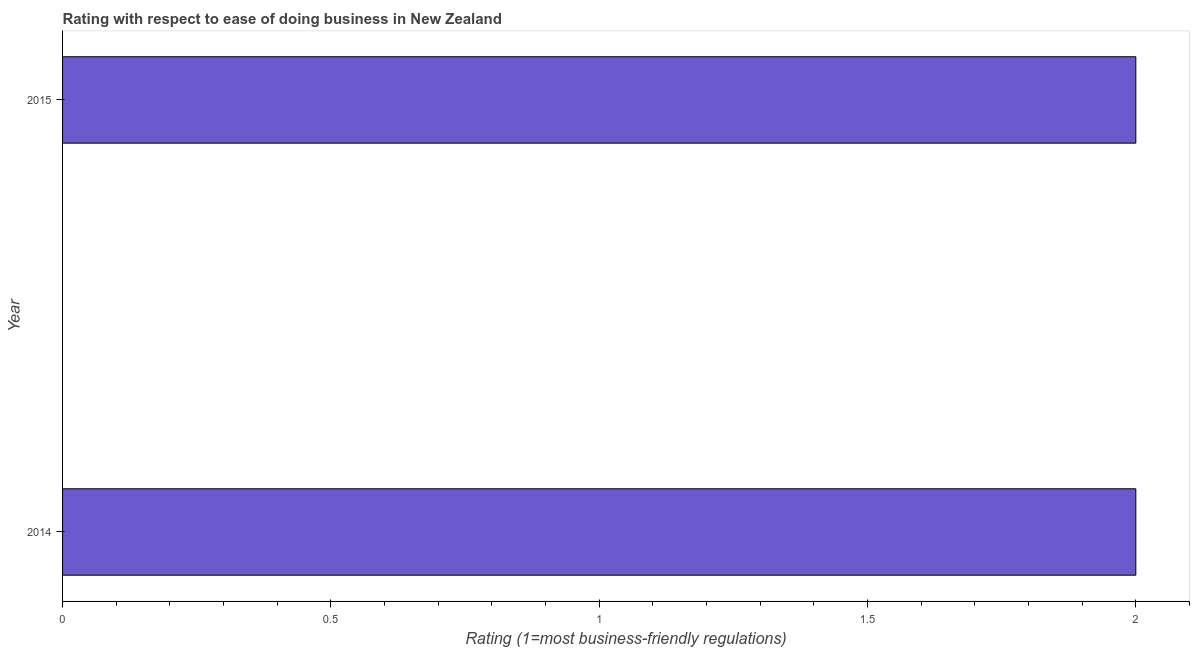Does the graph contain any zero values?
Give a very brief answer. No. Does the graph contain grids?
Your answer should be very brief. No. What is the title of the graph?
Give a very brief answer. Rating with respect to ease of doing business in New Zealand. What is the label or title of the X-axis?
Ensure brevity in your answer.  Rating (1=most business-friendly regulations). Across all years, what is the maximum ease of doing business index?
Keep it short and to the point. 2. What is the difference between the ease of doing business index in 2014 and 2015?
Your response must be concise. 0. What is the average ease of doing business index per year?
Ensure brevity in your answer.  2. What is the ratio of the ease of doing business index in 2014 to that in 2015?
Make the answer very short. 1. Is the ease of doing business index in 2014 less than that in 2015?
Offer a terse response. No. Are the values on the major ticks of X-axis written in scientific E-notation?
Provide a succinct answer. No. What is the Rating (1=most business-friendly regulations) in 2014?
Offer a very short reply. 2. What is the Rating (1=most business-friendly regulations) of 2015?
Make the answer very short. 2. 